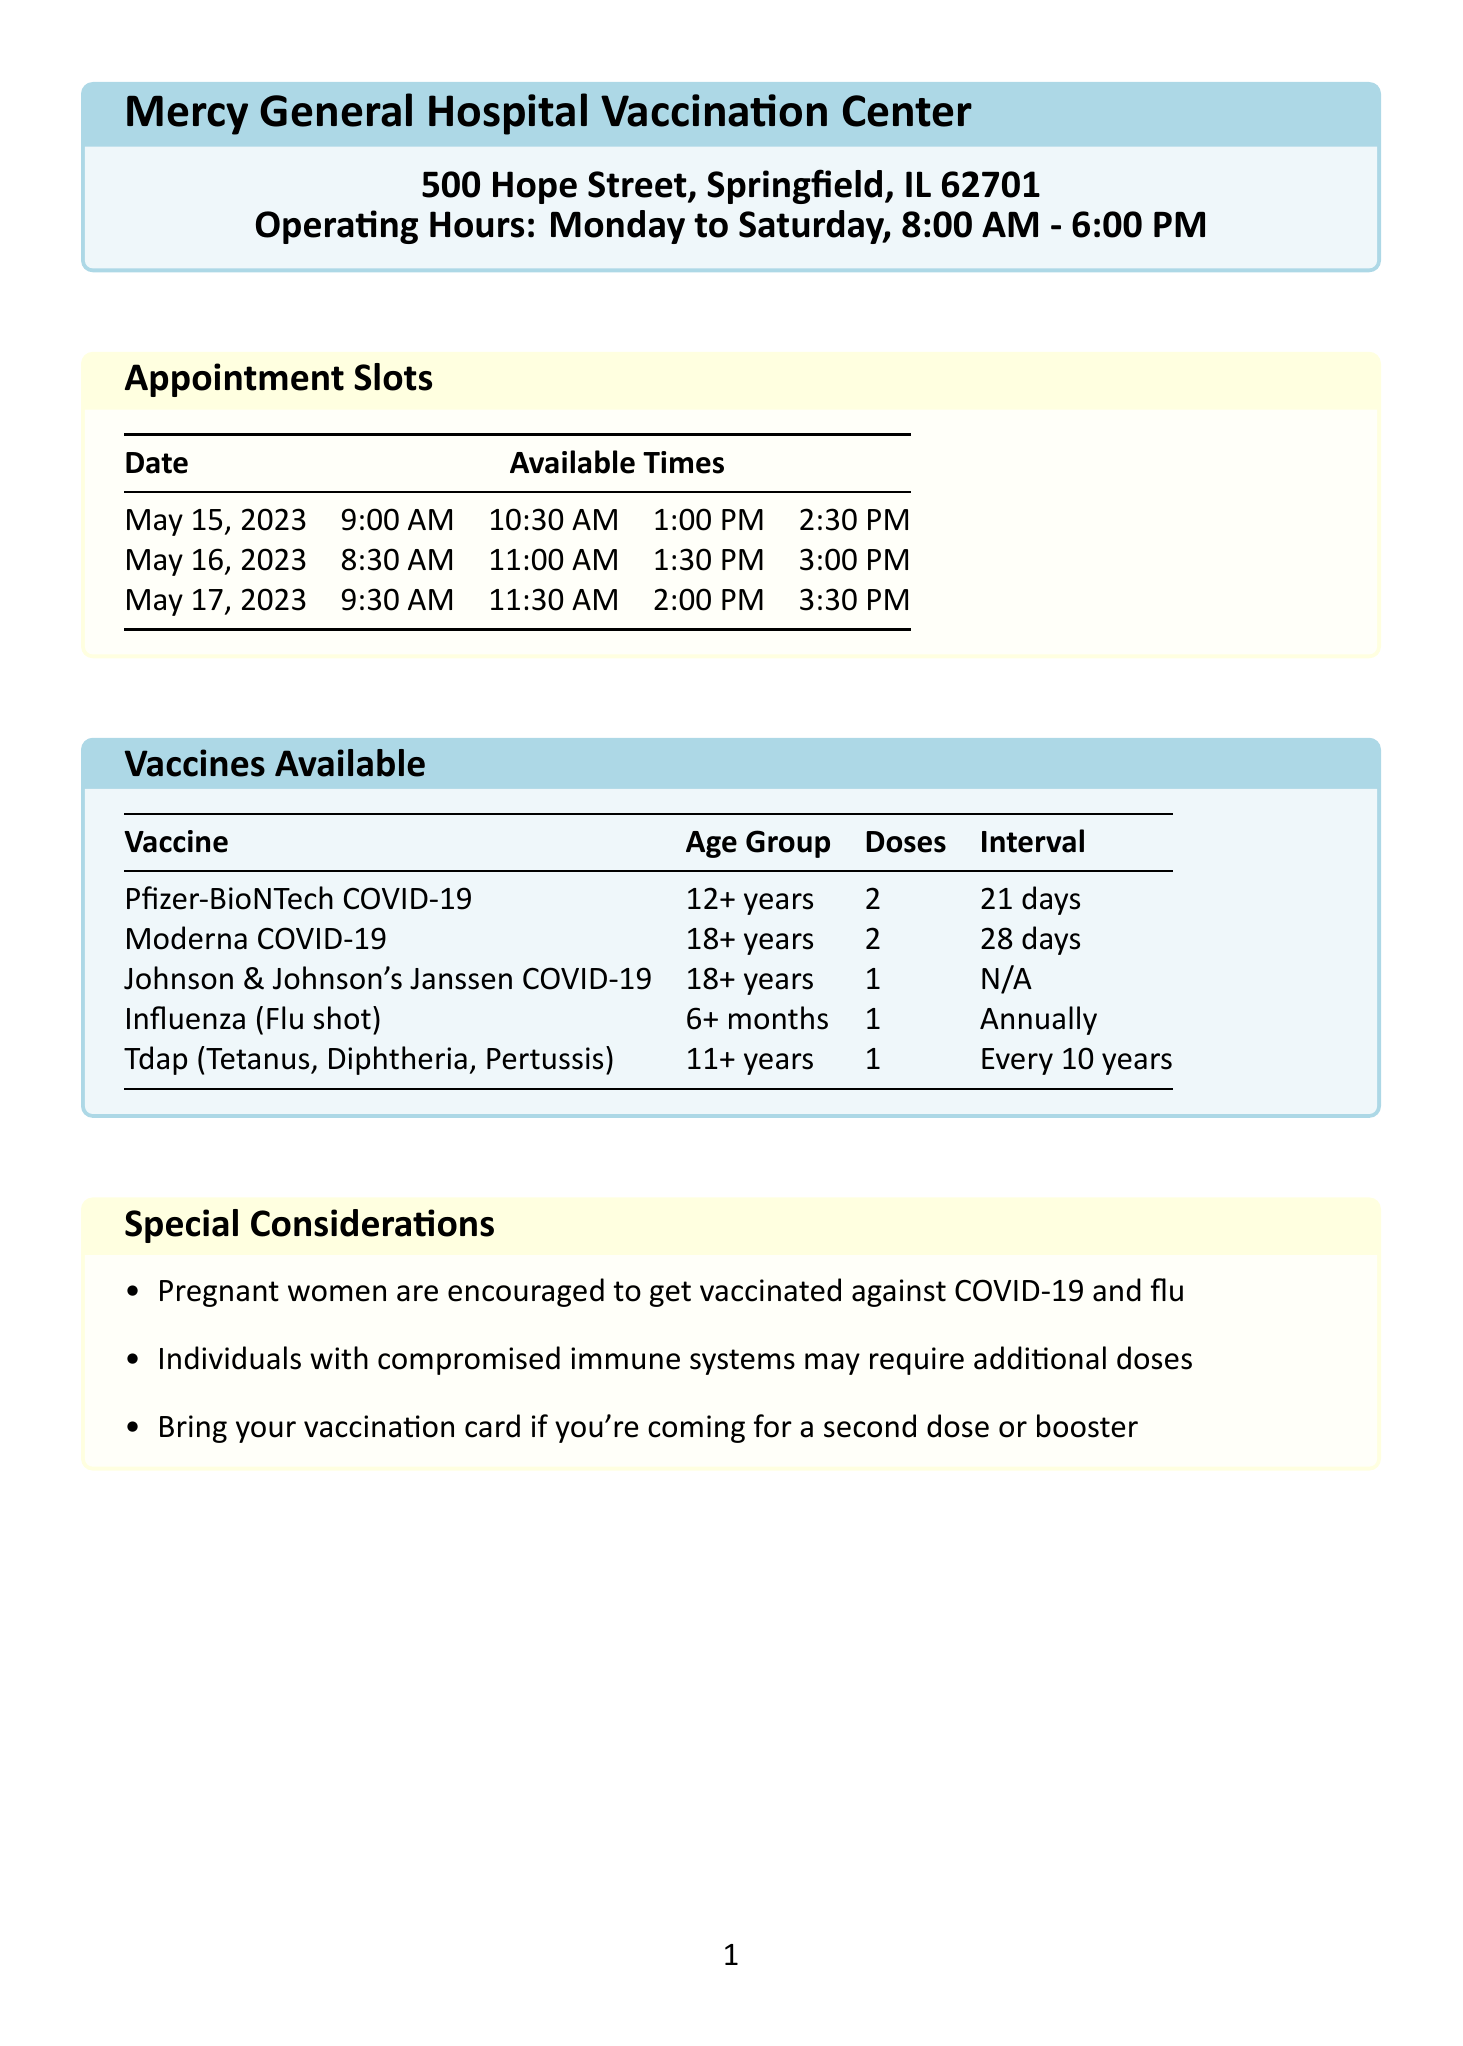What is the name of the clinic? The name of the clinic is stated in the document as the main title.
Answer: Mercy General Hospital Vaccination Center What are the operating hours? The operating hours are mentioned in a specific section.
Answer: Monday to Saturday, 8:00 AM - 6:00 PM How many total appointment slots are available on May 15, 2023? The date May 15, 2023, has five appointment times listed in the document.
Answer: 5 What type of vaccine requires only one dose? The document lists vaccine types along with the number of doses required for each.
Answer: Johnson & Johnson's Janssen COVID-19 What age group is eligible for the Influenza vaccine? The document specifies the age group for each vaccine.
Answer: 6 months and older What is the recommended interval for the Moderna vaccine? The document indicates the required interval between doses for the Moderna vaccine.
Answer: 28 days How early should patients arrive for their appointment? The patient instructions section provides a guideline for arrival time.
Answer: 10 minutes What should pregnant women consider regarding vaccinations? The document includes special considerations for pregnant women within a dedicated section.
Answer: Encouraged to get vaccinated against COVID-19 and flu How can patients contact the clinic? The document contains a section detailing contact information for the clinic.
Answer: (217) 555-1234 